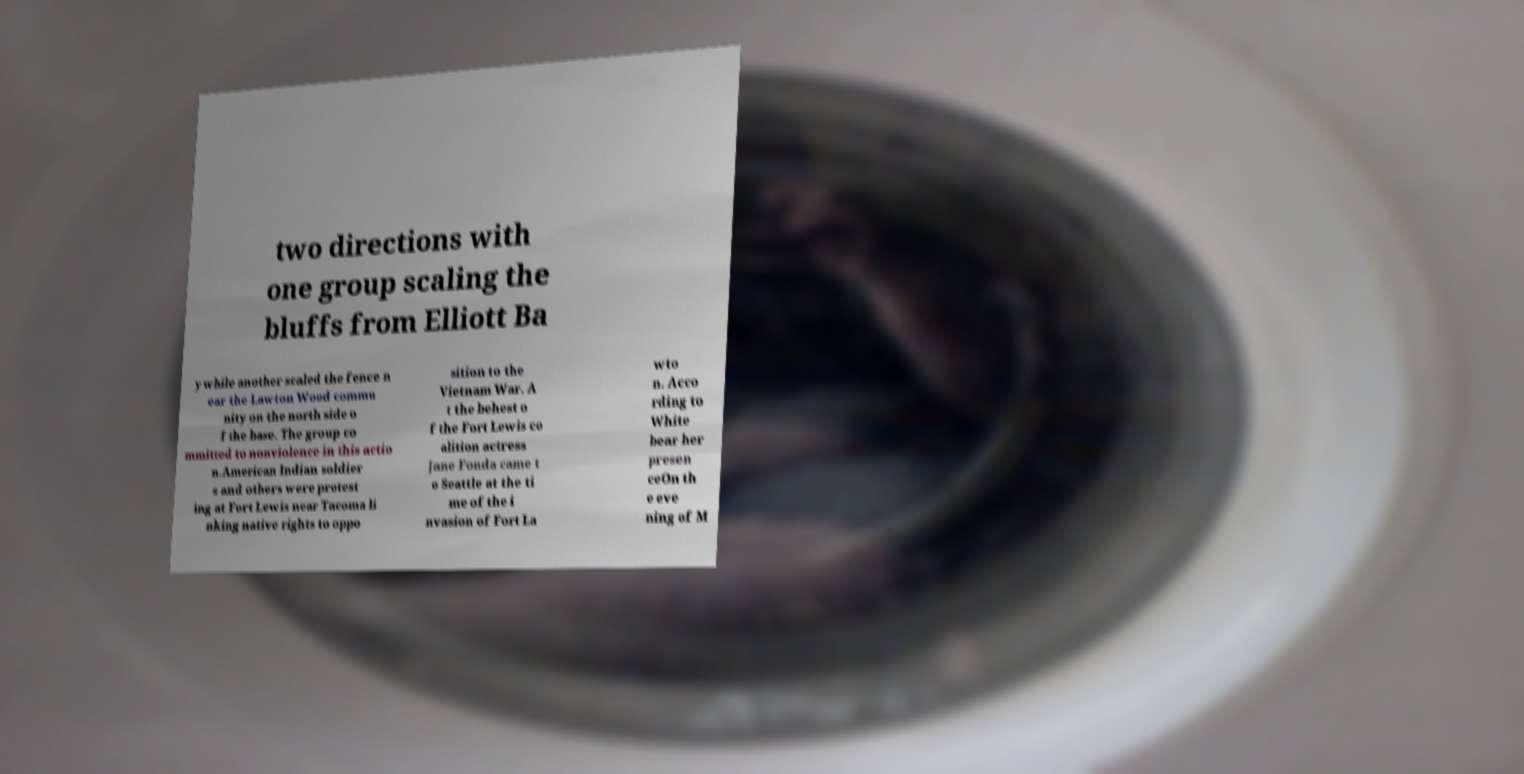Please identify and transcribe the text found in this image. two directions with one group scaling the bluffs from Elliott Ba y while another scaled the fence n ear the Lawton Wood commu nity on the north side o f the base. The group co mmitted to nonviolence in this actio n.American Indian soldier s and others were protest ing at Fort Lewis near Tacoma li nking native rights to oppo sition to the Vietnam War. A t the behest o f the Fort Lewis co alition actress Jane Fonda came t o Seattle at the ti me of the i nvasion of Fort La wto n. Acco rding to White bear her presen ceOn th e eve ning of M 